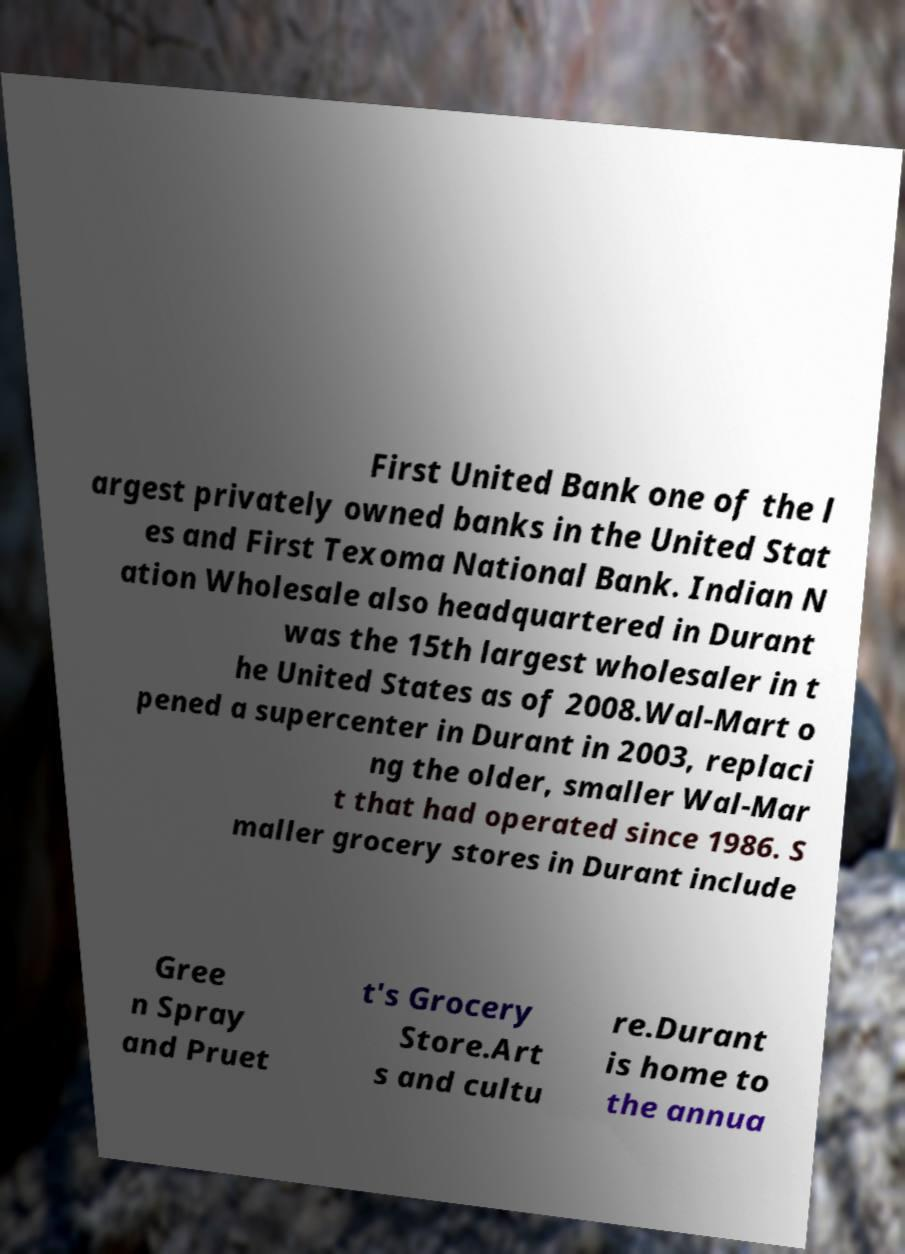Please read and relay the text visible in this image. What does it say? First United Bank one of the l argest privately owned banks in the United Stat es and First Texoma National Bank. Indian N ation Wholesale also headquartered in Durant was the 15th largest wholesaler in t he United States as of 2008.Wal-Mart o pened a supercenter in Durant in 2003, replaci ng the older, smaller Wal-Mar t that had operated since 1986. S maller grocery stores in Durant include Gree n Spray and Pruet t's Grocery Store.Art s and cultu re.Durant is home to the annua 